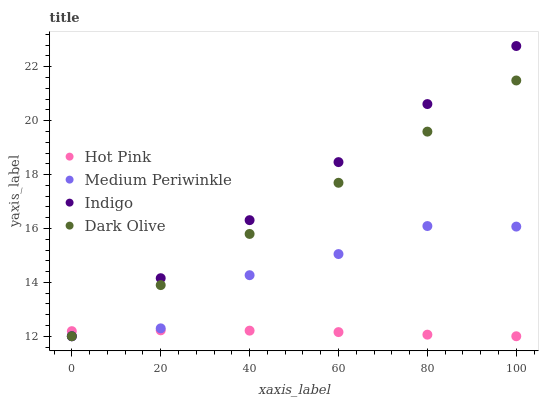Does Hot Pink have the minimum area under the curve?
Answer yes or no. Yes. Does Indigo have the maximum area under the curve?
Answer yes or no. Yes. Does Indigo have the minimum area under the curve?
Answer yes or no. No. Does Hot Pink have the maximum area under the curve?
Answer yes or no. No. Is Indigo the smoothest?
Answer yes or no. Yes. Is Medium Periwinkle the roughest?
Answer yes or no. Yes. Is Hot Pink the smoothest?
Answer yes or no. No. Is Hot Pink the roughest?
Answer yes or no. No. Does Dark Olive have the lowest value?
Answer yes or no. Yes. Does Indigo have the highest value?
Answer yes or no. Yes. Does Hot Pink have the highest value?
Answer yes or no. No. Does Hot Pink intersect Dark Olive?
Answer yes or no. Yes. Is Hot Pink less than Dark Olive?
Answer yes or no. No. Is Hot Pink greater than Dark Olive?
Answer yes or no. No. 